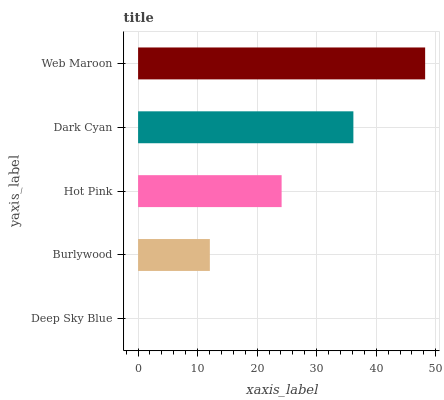Is Deep Sky Blue the minimum?
Answer yes or no. Yes. Is Web Maroon the maximum?
Answer yes or no. Yes. Is Burlywood the minimum?
Answer yes or no. No. Is Burlywood the maximum?
Answer yes or no. No. Is Burlywood greater than Deep Sky Blue?
Answer yes or no. Yes. Is Deep Sky Blue less than Burlywood?
Answer yes or no. Yes. Is Deep Sky Blue greater than Burlywood?
Answer yes or no. No. Is Burlywood less than Deep Sky Blue?
Answer yes or no. No. Is Hot Pink the high median?
Answer yes or no. Yes. Is Hot Pink the low median?
Answer yes or no. Yes. Is Dark Cyan the high median?
Answer yes or no. No. Is Dark Cyan the low median?
Answer yes or no. No. 